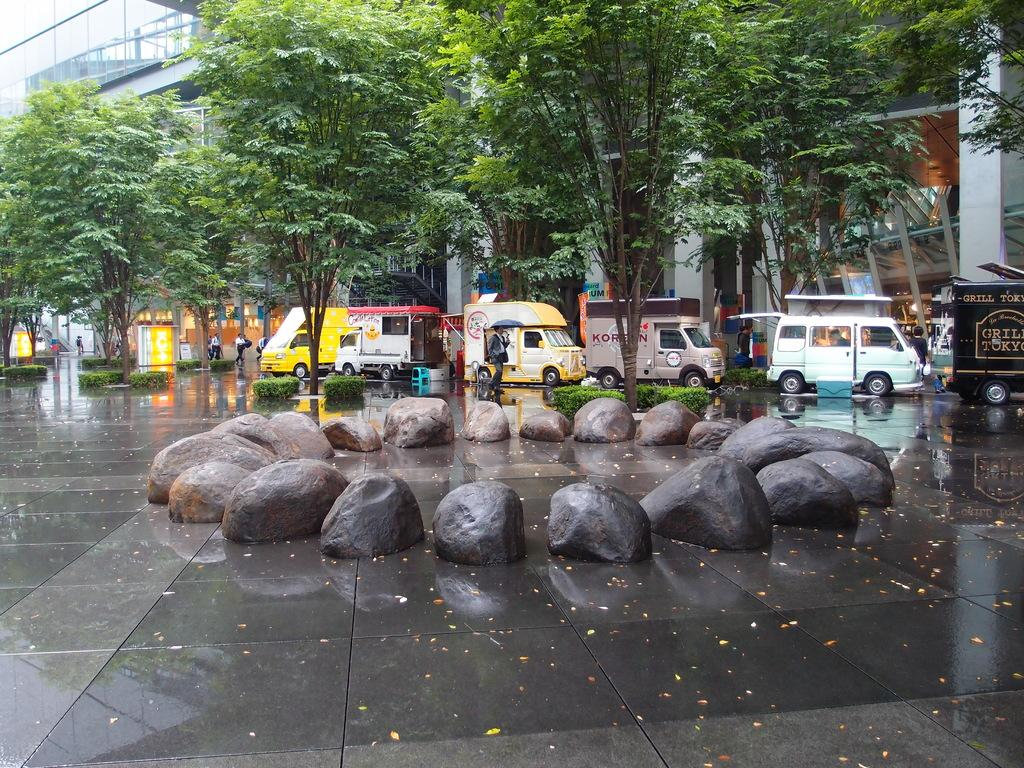What is on the floor in the image? There are stones on the floor in the image. What can be seen in the distance in the image? There are buildings, a vehicle, people walking, and trees in the background of the image. What type of key is being used to start the truck in the image? There is no truck or key present in the image. Can you tell me where the father is located in the image? There is no mention of a father or any person's relationship in the image. 